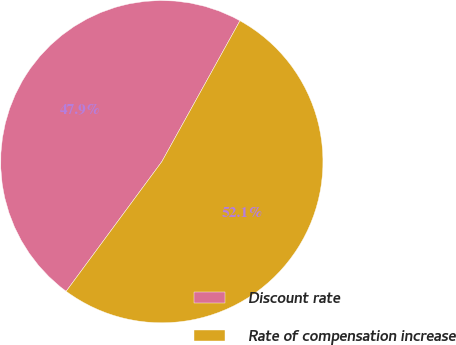Convert chart to OTSL. <chart><loc_0><loc_0><loc_500><loc_500><pie_chart><fcel>Discount rate<fcel>Rate of compensation increase<nl><fcel>47.94%<fcel>52.06%<nl></chart> 